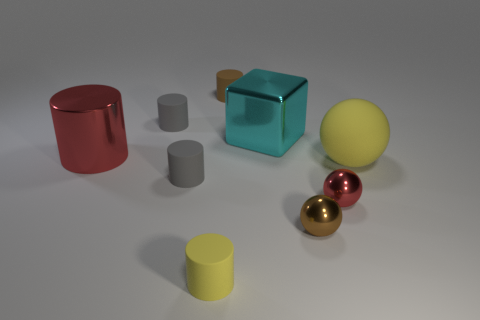What is the color of the large metallic object that is the same shape as the small yellow matte thing?
Offer a terse response. Red. There is a large rubber sphere; is it the same color as the matte cylinder that is in front of the small brown metallic thing?
Keep it short and to the point. Yes. What shape is the small rubber thing that is left of the yellow matte cylinder and in front of the big yellow rubber object?
Make the answer very short. Cylinder. Is the number of tiny brown metal objects less than the number of gray things?
Ensure brevity in your answer.  Yes. Is there a cyan cylinder?
Your answer should be compact. No. How many other things are there of the same size as the red shiny cylinder?
Provide a short and direct response. 2. Does the red ball have the same material as the tiny gray object that is behind the big shiny block?
Provide a short and direct response. No. Are there an equal number of red metal balls on the left side of the shiny cylinder and red cylinders on the left side of the tiny brown metallic object?
Your answer should be compact. No. What is the material of the yellow sphere?
Provide a short and direct response. Rubber. What color is the metallic cube that is the same size as the red metal cylinder?
Offer a terse response. Cyan. 